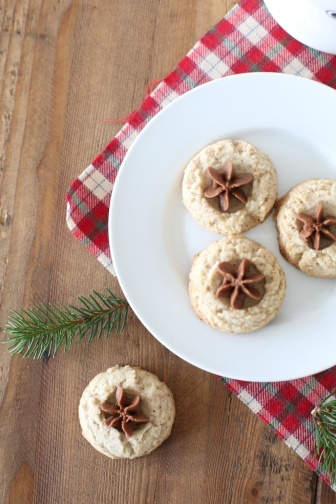How might these cookies be presented at a holiday party? At a holiday party, these elegant sugar cookies could be presented on a charming wooden tray, lined with a festive red and white checkered cloth. Surrounding the tray, sprigs of pine and twinkling fairy lights would add to the enchanting presentation. Placed centrally among other traditional holiday treats like gingerbread and peppermint bark, these cookies, with their star anise decoration, would stand out as a delightful and aromatic centerpiece, inviting guests to partake in their seasonal charm. 